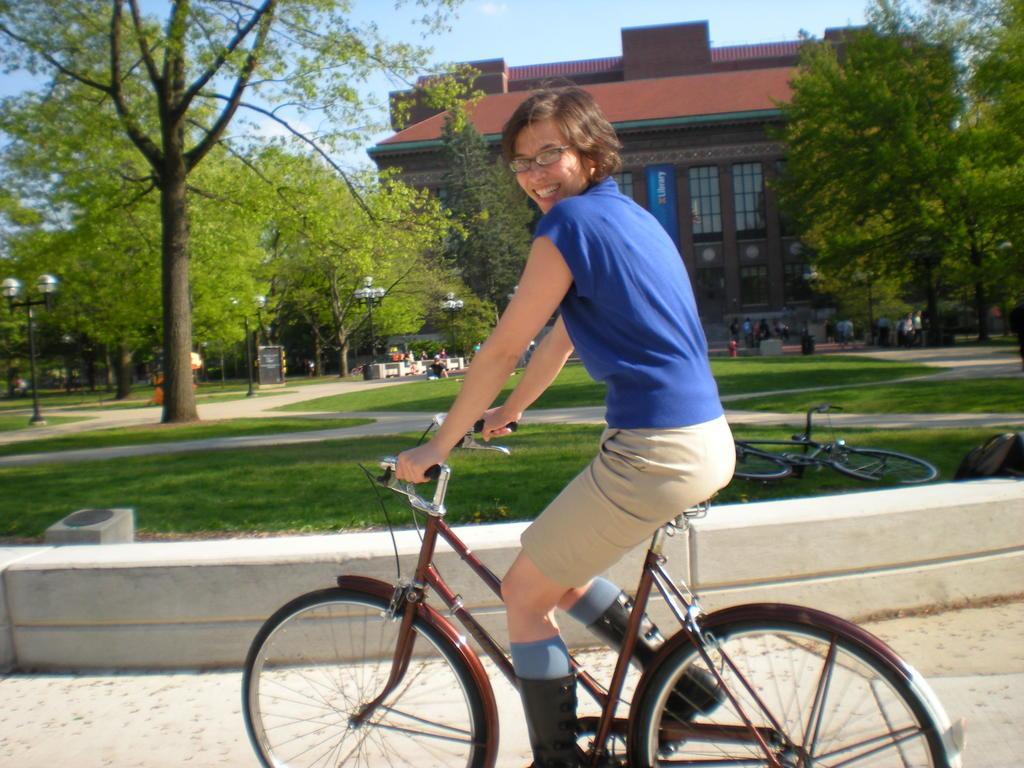How would you summarize this image in a sentence or two? Here is a woman sitting and riding a bicycle. At background I can see a building and trees. I can find another bicycles in the grass. This looks like a street light. I can see few people standing at the background. 